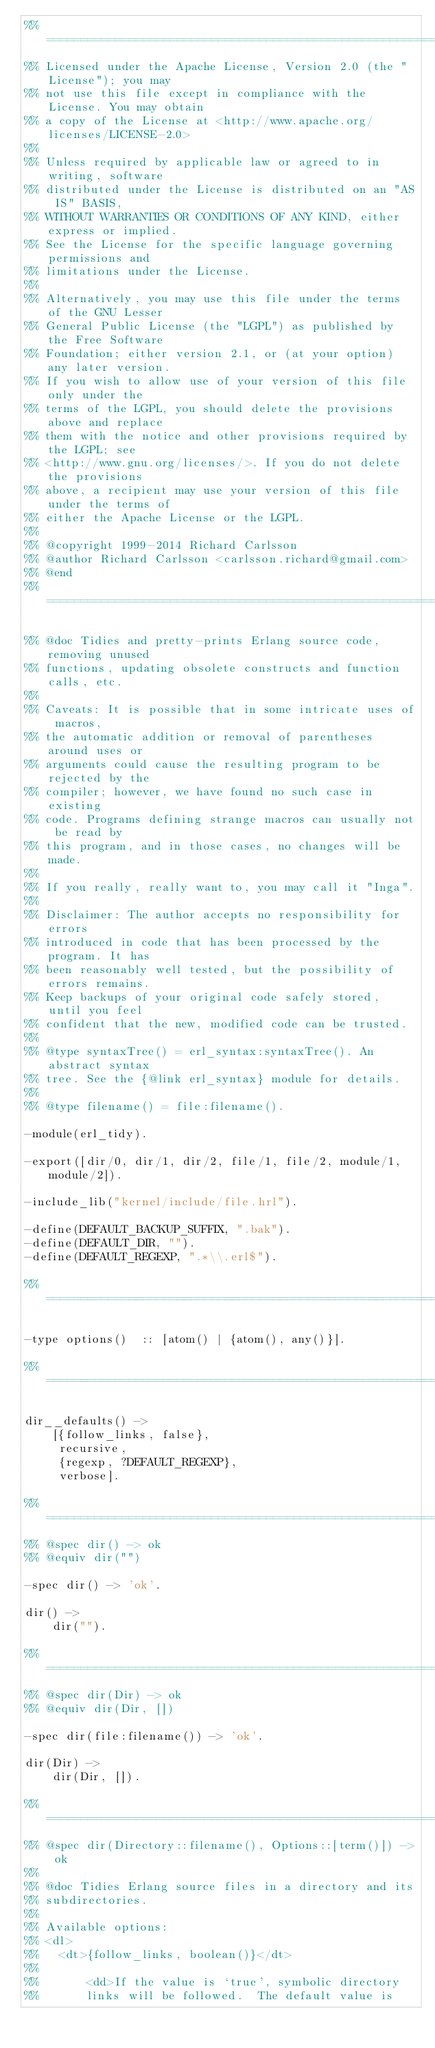Convert code to text. <code><loc_0><loc_0><loc_500><loc_500><_Erlang_>%% =====================================================================
%% Licensed under the Apache License, Version 2.0 (the "License"); you may
%% not use this file except in compliance with the License. You may obtain
%% a copy of the License at <http://www.apache.org/licenses/LICENSE-2.0>
%%
%% Unless required by applicable law or agreed to in writing, software
%% distributed under the License is distributed on an "AS IS" BASIS,
%% WITHOUT WARRANTIES OR CONDITIONS OF ANY KIND, either express or implied.
%% See the License for the specific language governing permissions and
%% limitations under the License.
%%
%% Alternatively, you may use this file under the terms of the GNU Lesser
%% General Public License (the "LGPL") as published by the Free Software
%% Foundation; either version 2.1, or (at your option) any later version.
%% If you wish to allow use of your version of this file only under the
%% terms of the LGPL, you should delete the provisions above and replace
%% them with the notice and other provisions required by the LGPL; see
%% <http://www.gnu.org/licenses/>. If you do not delete the provisions
%% above, a recipient may use your version of this file under the terms of
%% either the Apache License or the LGPL.
%%
%% @copyright 1999-2014 Richard Carlsson
%% @author Richard Carlsson <carlsson.richard@gmail.com>
%% @end
%% =====================================================================

%% @doc Tidies and pretty-prints Erlang source code, removing unused
%% functions, updating obsolete constructs and function calls, etc.
%%
%% Caveats: It is possible that in some intricate uses of macros,
%% the automatic addition or removal of parentheses around uses or
%% arguments could cause the resulting program to be rejected by the
%% compiler; however, we have found no such case in existing
%% code. Programs defining strange macros can usually not be read by
%% this program, and in those cases, no changes will be made.
%%
%% If you really, really want to, you may call it "Inga".
%%
%% Disclaimer: The author accepts no responsibility for errors
%% introduced in code that has been processed by the program. It has
%% been reasonably well tested, but the possibility of errors remains.
%% Keep backups of your original code safely stored, until you feel
%% confident that the new, modified code can be trusted.
%%
%% @type syntaxTree() = erl_syntax:syntaxTree(). An abstract syntax
%% tree. See the {@link erl_syntax} module for details.
%%
%% @type filename() = file:filename().

-module(erl_tidy).

-export([dir/0, dir/1, dir/2, file/1, file/2, module/1, module/2]).

-include_lib("kernel/include/file.hrl").

-define(DEFAULT_BACKUP_SUFFIX, ".bak").
-define(DEFAULT_DIR, "").
-define(DEFAULT_REGEXP, ".*\\.erl$").

%% =====================================================================

-type options()  :: [atom() | {atom(), any()}].

%% =====================================================================

dir__defaults() ->
    [{follow_links, false},
     recursive,
     {regexp, ?DEFAULT_REGEXP},
     verbose].

%% =====================================================================
%% @spec dir() -> ok
%% @equiv dir("")

-spec dir() -> 'ok'.

dir() ->
    dir("").

%% =====================================================================
%% @spec dir(Dir) -> ok
%% @equiv dir(Dir, [])

-spec dir(file:filename()) -> 'ok'.

dir(Dir) ->
    dir(Dir, []).

%% =====================================================================
%% @spec dir(Directory::filename(), Options::[term()]) -> ok
%%
%% @doc Tidies Erlang source files in a directory and its
%% subdirectories.
%%
%% Available options:
%% <dl>
%%   <dt>{follow_links, boolean()}</dt>
%%
%%       <dd>If the value is `true', symbolic directory
%%       links will be followed.  The default value is</code> 